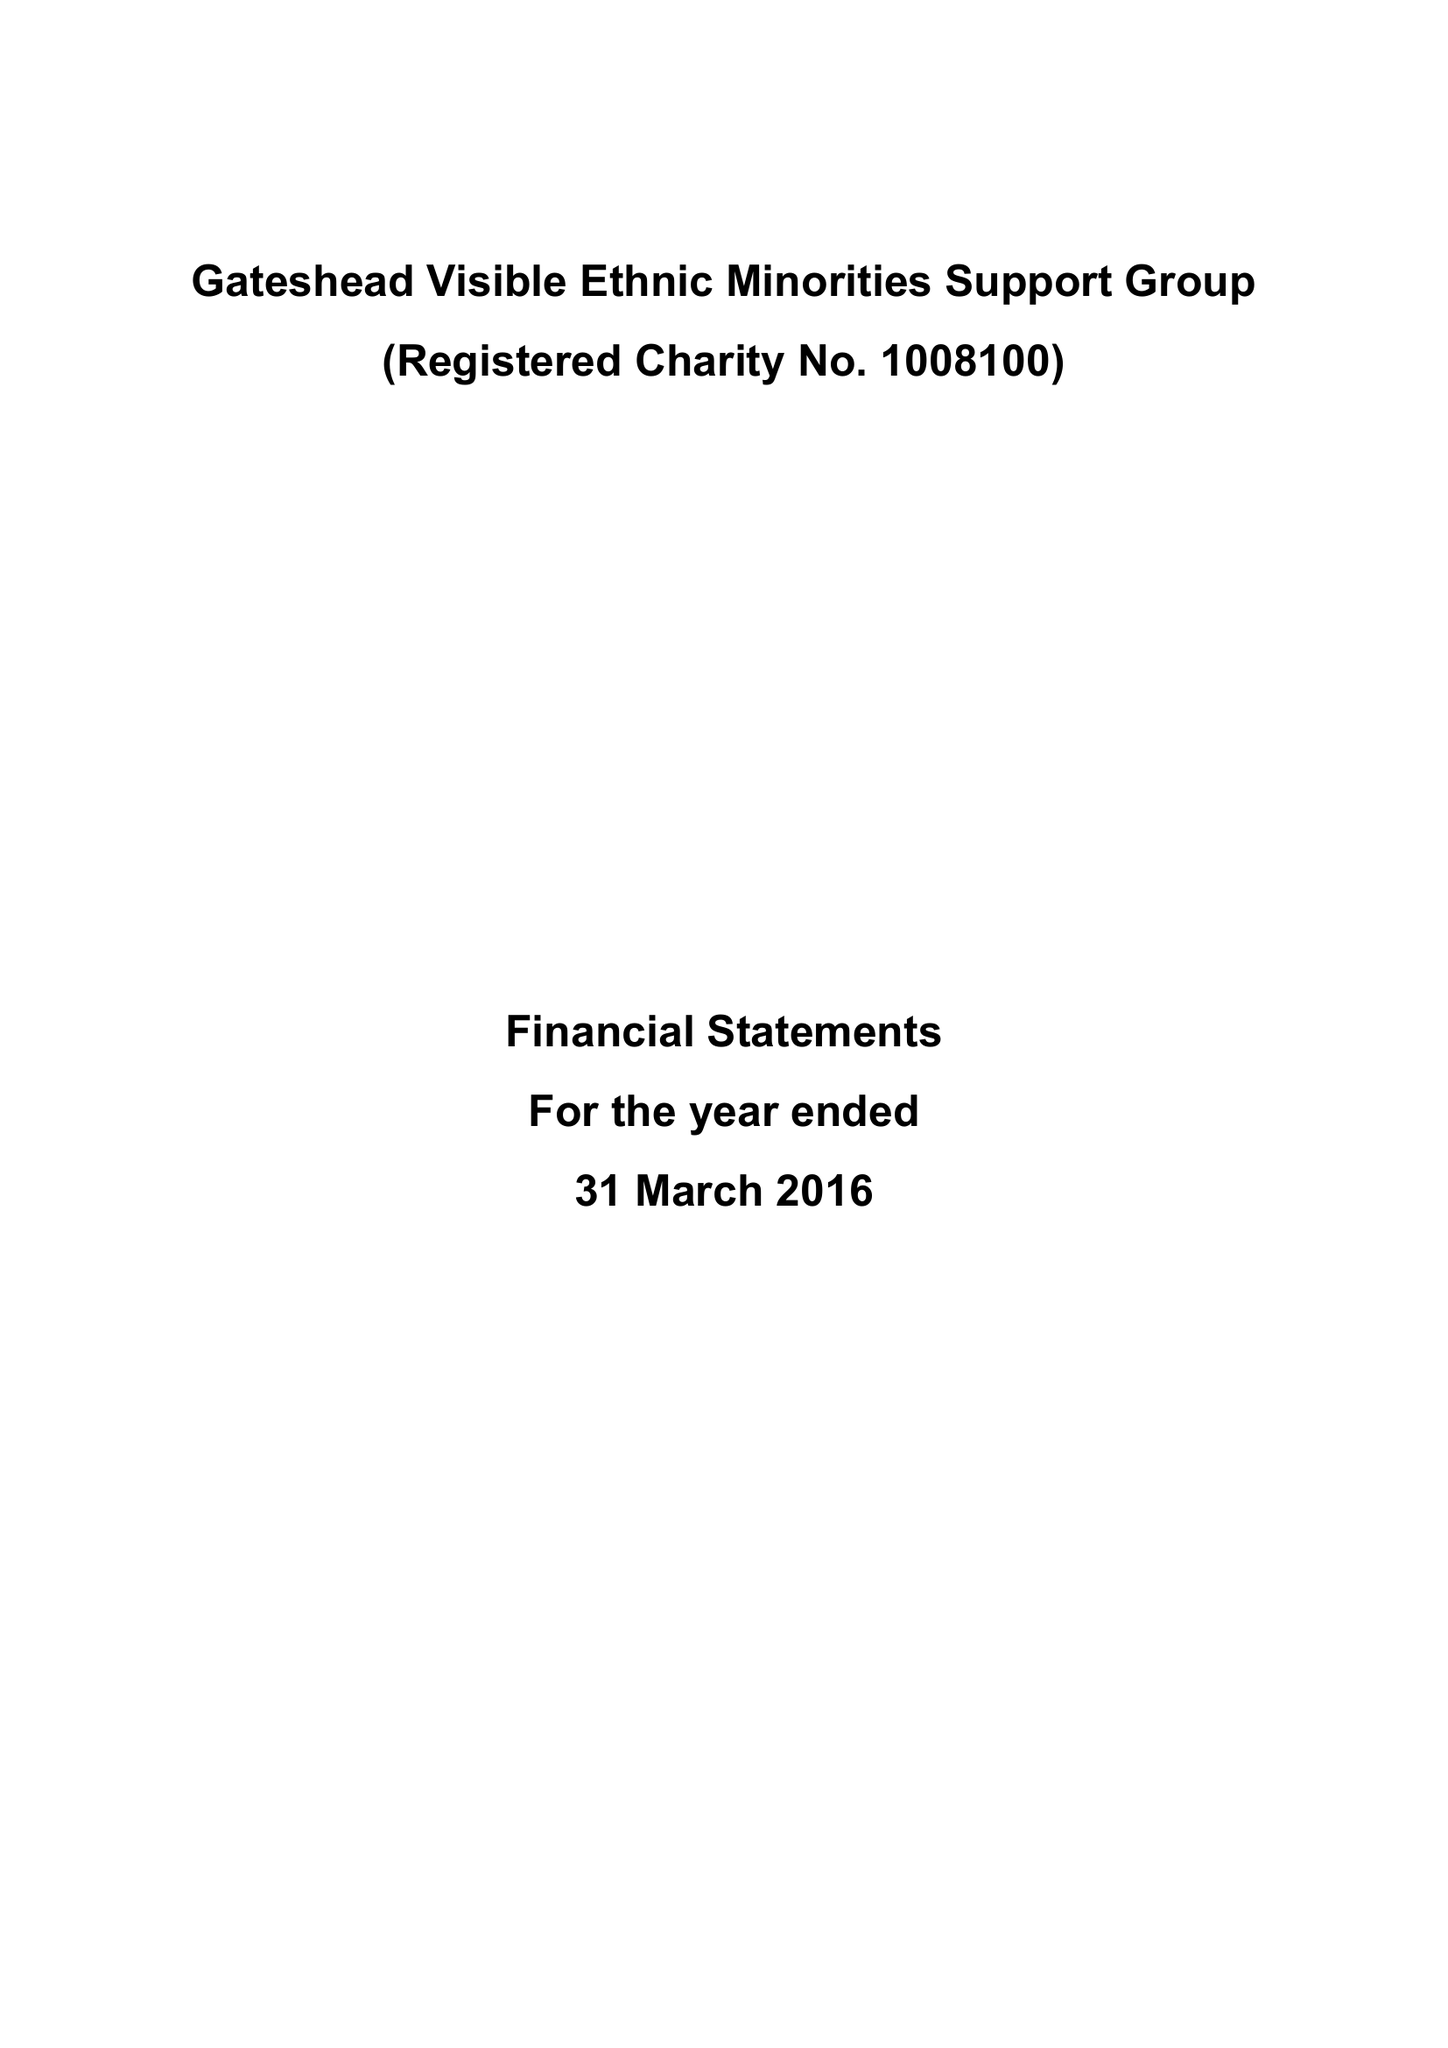What is the value for the income_annually_in_british_pounds?
Answer the question using a single word or phrase. 260859.00 